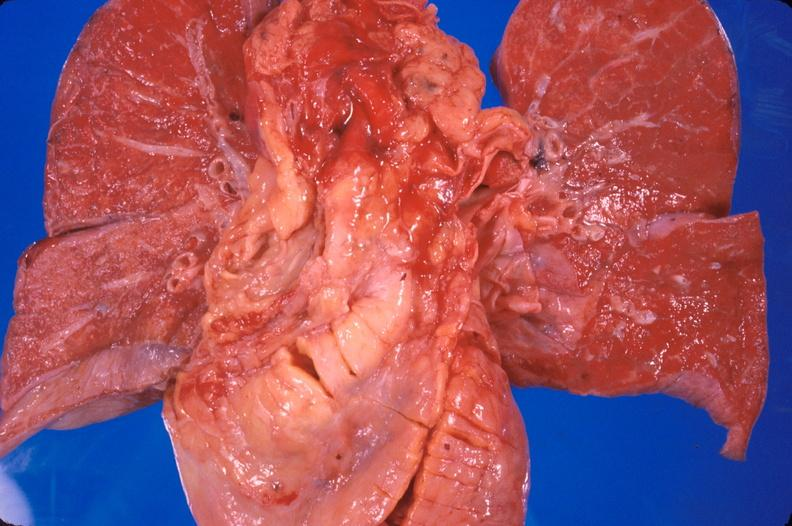where is this?
Answer the question using a single word or phrase. Heart 